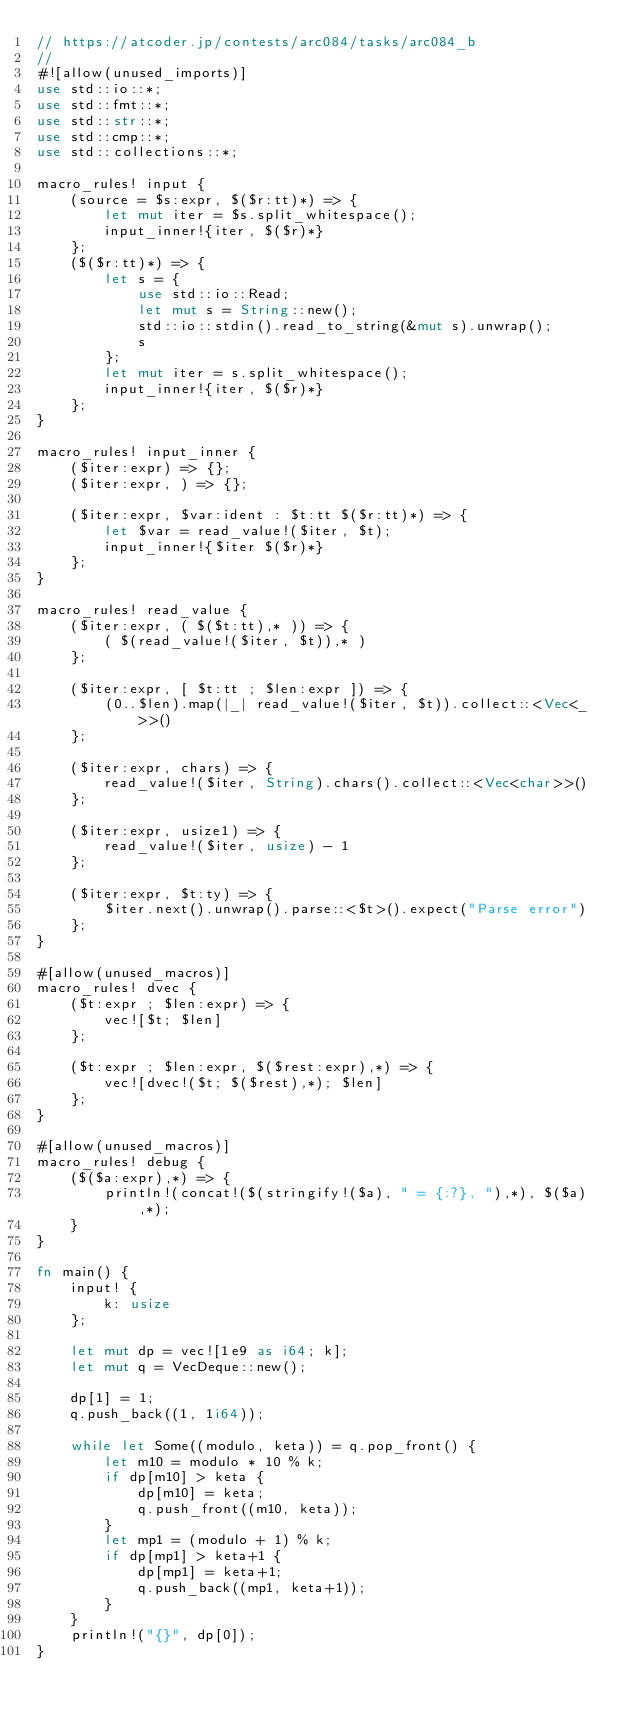Convert code to text. <code><loc_0><loc_0><loc_500><loc_500><_Rust_>// https://atcoder.jp/contests/arc084/tasks/arc084_b
//
#![allow(unused_imports)]
use std::io::*;
use std::fmt::*;
use std::str::*;
use std::cmp::*;
use std::collections::*;

macro_rules! input {
    (source = $s:expr, $($r:tt)*) => {
        let mut iter = $s.split_whitespace();
        input_inner!{iter, $($r)*}
    };
    ($($r:tt)*) => {
        let s = {
            use std::io::Read;
            let mut s = String::new();
            std::io::stdin().read_to_string(&mut s).unwrap();
            s
        };
        let mut iter = s.split_whitespace();
        input_inner!{iter, $($r)*}
    };
}

macro_rules! input_inner {
    ($iter:expr) => {};
    ($iter:expr, ) => {};

    ($iter:expr, $var:ident : $t:tt $($r:tt)*) => {
        let $var = read_value!($iter, $t);
        input_inner!{$iter $($r)*}
    };
}

macro_rules! read_value {
    ($iter:expr, ( $($t:tt),* )) => {
        ( $(read_value!($iter, $t)),* )
    };

    ($iter:expr, [ $t:tt ; $len:expr ]) => {
        (0..$len).map(|_| read_value!($iter, $t)).collect::<Vec<_>>()
    };

    ($iter:expr, chars) => {
        read_value!($iter, String).chars().collect::<Vec<char>>()
    };

    ($iter:expr, usize1) => {
        read_value!($iter, usize) - 1
    };

    ($iter:expr, $t:ty) => {
        $iter.next().unwrap().parse::<$t>().expect("Parse error")
    };
}

#[allow(unused_macros)]
macro_rules! dvec {
    ($t:expr ; $len:expr) => {
        vec![$t; $len]
    };

    ($t:expr ; $len:expr, $($rest:expr),*) => {
        vec![dvec!($t; $($rest),*); $len]
    };
}

#[allow(unused_macros)]
macro_rules! debug {
    ($($a:expr),*) => {
        println!(concat!($(stringify!($a), " = {:?}, "),*), $($a),*);
    }
}

fn main() {
    input! {
        k: usize
    };

    let mut dp = vec![1e9 as i64; k];
    let mut q = VecDeque::new();

    dp[1] = 1;
    q.push_back((1, 1i64));

    while let Some((modulo, keta)) = q.pop_front() {
        let m10 = modulo * 10 % k;
        if dp[m10] > keta {
            dp[m10] = keta;
            q.push_front((m10, keta));
        }
        let mp1 = (modulo + 1) % k;
        if dp[mp1] > keta+1 {
            dp[mp1] = keta+1;
            q.push_back((mp1, keta+1));
        }
    }
    println!("{}", dp[0]);
}
</code> 